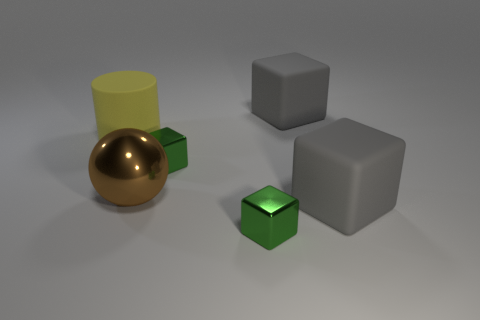There is a rubber thing that is both behind the brown metallic ball and on the right side of the yellow thing; what size is it?
Provide a short and direct response. Large. How many gray matte cubes have the same size as the brown object?
Your answer should be compact. 2. There is a gray rubber block on the right side of the gray matte cube that is behind the large rubber cylinder; what is its size?
Your response must be concise. Large. There is a gray object that is behind the brown sphere; is it the same shape as the metallic thing behind the brown shiny sphere?
Give a very brief answer. Yes. What color is the block that is both in front of the yellow object and behind the metal ball?
Offer a very short reply. Green. There is a small thing in front of the big brown sphere; what is its color?
Offer a terse response. Green. Is there a big brown metallic ball that is on the left side of the green object that is in front of the large brown thing?
Provide a succinct answer. Yes. Do the large matte cylinder and the big block that is behind the yellow rubber thing have the same color?
Provide a short and direct response. No. Are there any green cubes made of the same material as the large brown ball?
Your answer should be compact. Yes. What number of tiny metal cylinders are there?
Ensure brevity in your answer.  0. 